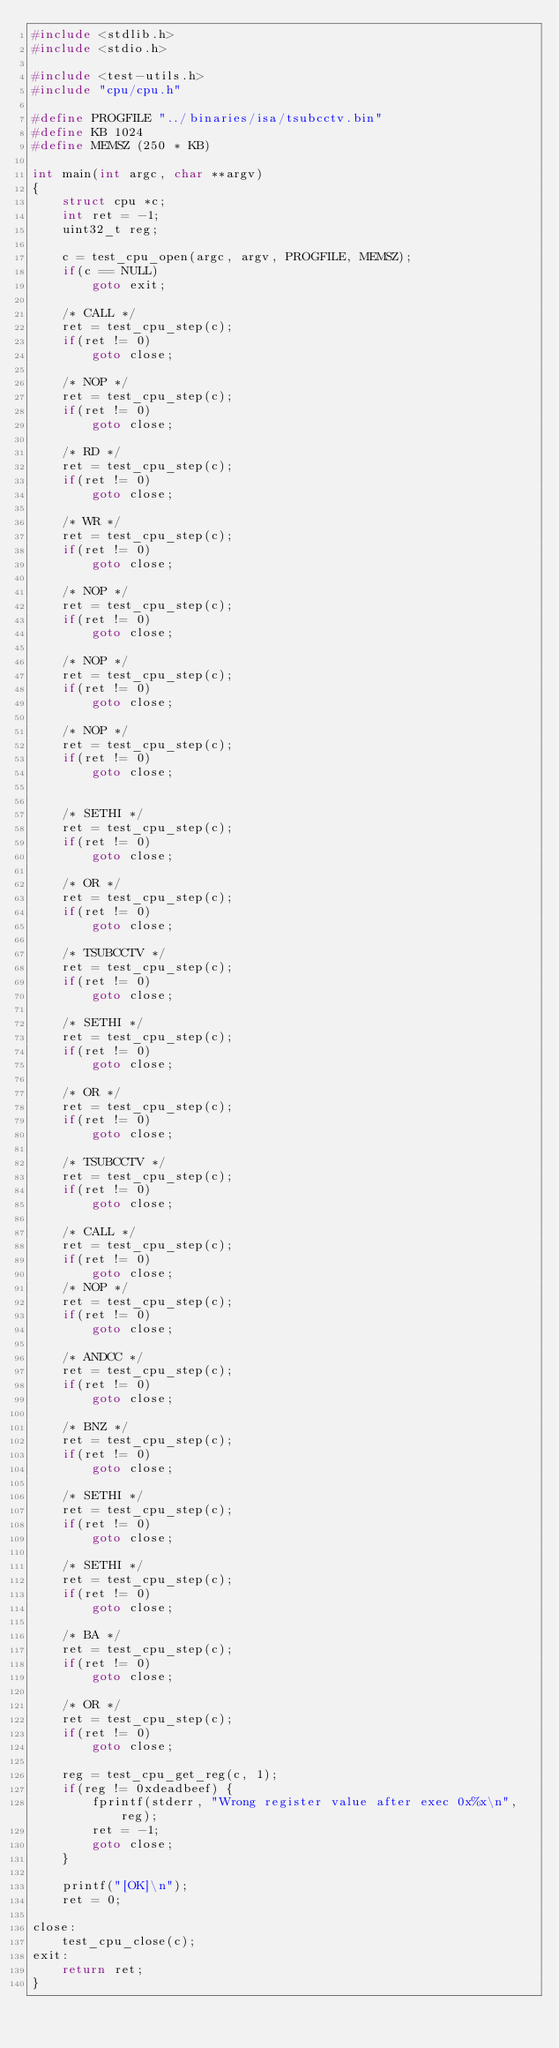Convert code to text. <code><loc_0><loc_0><loc_500><loc_500><_C_>#include <stdlib.h>
#include <stdio.h>

#include <test-utils.h>
#include "cpu/cpu.h"

#define PROGFILE "../binaries/isa/tsubcctv.bin"
#define KB 1024
#define MEMSZ (250 * KB)

int main(int argc, char **argv)
{
	struct cpu *c;
	int ret = -1;
	uint32_t reg;

	c = test_cpu_open(argc, argv, PROGFILE, MEMSZ);
	if(c == NULL)
		goto exit;

	/* CALL */
	ret = test_cpu_step(c);
	if(ret != 0)
		goto close;

	/* NOP */
	ret = test_cpu_step(c);
	if(ret != 0)
		goto close;

	/* RD */
	ret = test_cpu_step(c);
	if(ret != 0)
		goto close;

	/* WR */
	ret = test_cpu_step(c);
	if(ret != 0)
		goto close;

	/* NOP */
	ret = test_cpu_step(c);
	if(ret != 0)
		goto close;

	/* NOP */
	ret = test_cpu_step(c);
	if(ret != 0)
		goto close;

	/* NOP */
	ret = test_cpu_step(c);
	if(ret != 0)
		goto close;


	/* SETHI */
	ret = test_cpu_step(c);
	if(ret != 0)
		goto close;

	/* OR */
	ret = test_cpu_step(c);
	if(ret != 0)
		goto close;

	/* TSUBCCTV */
	ret = test_cpu_step(c);
	if(ret != 0)
		goto close;

	/* SETHI */
	ret = test_cpu_step(c);
	if(ret != 0)
		goto close;

	/* OR */
	ret = test_cpu_step(c);
	if(ret != 0)
		goto close;

	/* TSUBCCTV */
	ret = test_cpu_step(c);
	if(ret != 0)
		goto close;

	/* CALL */
	ret = test_cpu_step(c);
	if(ret != 0)
		goto close;
	/* NOP */
	ret = test_cpu_step(c);
	if(ret != 0)
		goto close;

	/* ANDCC */
	ret = test_cpu_step(c);
	if(ret != 0)
		goto close;

	/* BNZ */
	ret = test_cpu_step(c);
	if(ret != 0)
		goto close;

	/* SETHI */
	ret = test_cpu_step(c);
	if(ret != 0)
		goto close;

	/* SETHI */
	ret = test_cpu_step(c);
	if(ret != 0)
		goto close;

	/* BA */
	ret = test_cpu_step(c);
	if(ret != 0)
		goto close;

	/* OR */
	ret = test_cpu_step(c);
	if(ret != 0)
		goto close;

	reg = test_cpu_get_reg(c, 1);
	if(reg != 0xdeadbeef) {
		fprintf(stderr, "Wrong register value after exec 0x%x\n", reg);
		ret = -1;
		goto close;
	}

	printf("[OK]\n");
	ret = 0;

close:
	test_cpu_close(c);
exit:
	return ret;
}
</code> 